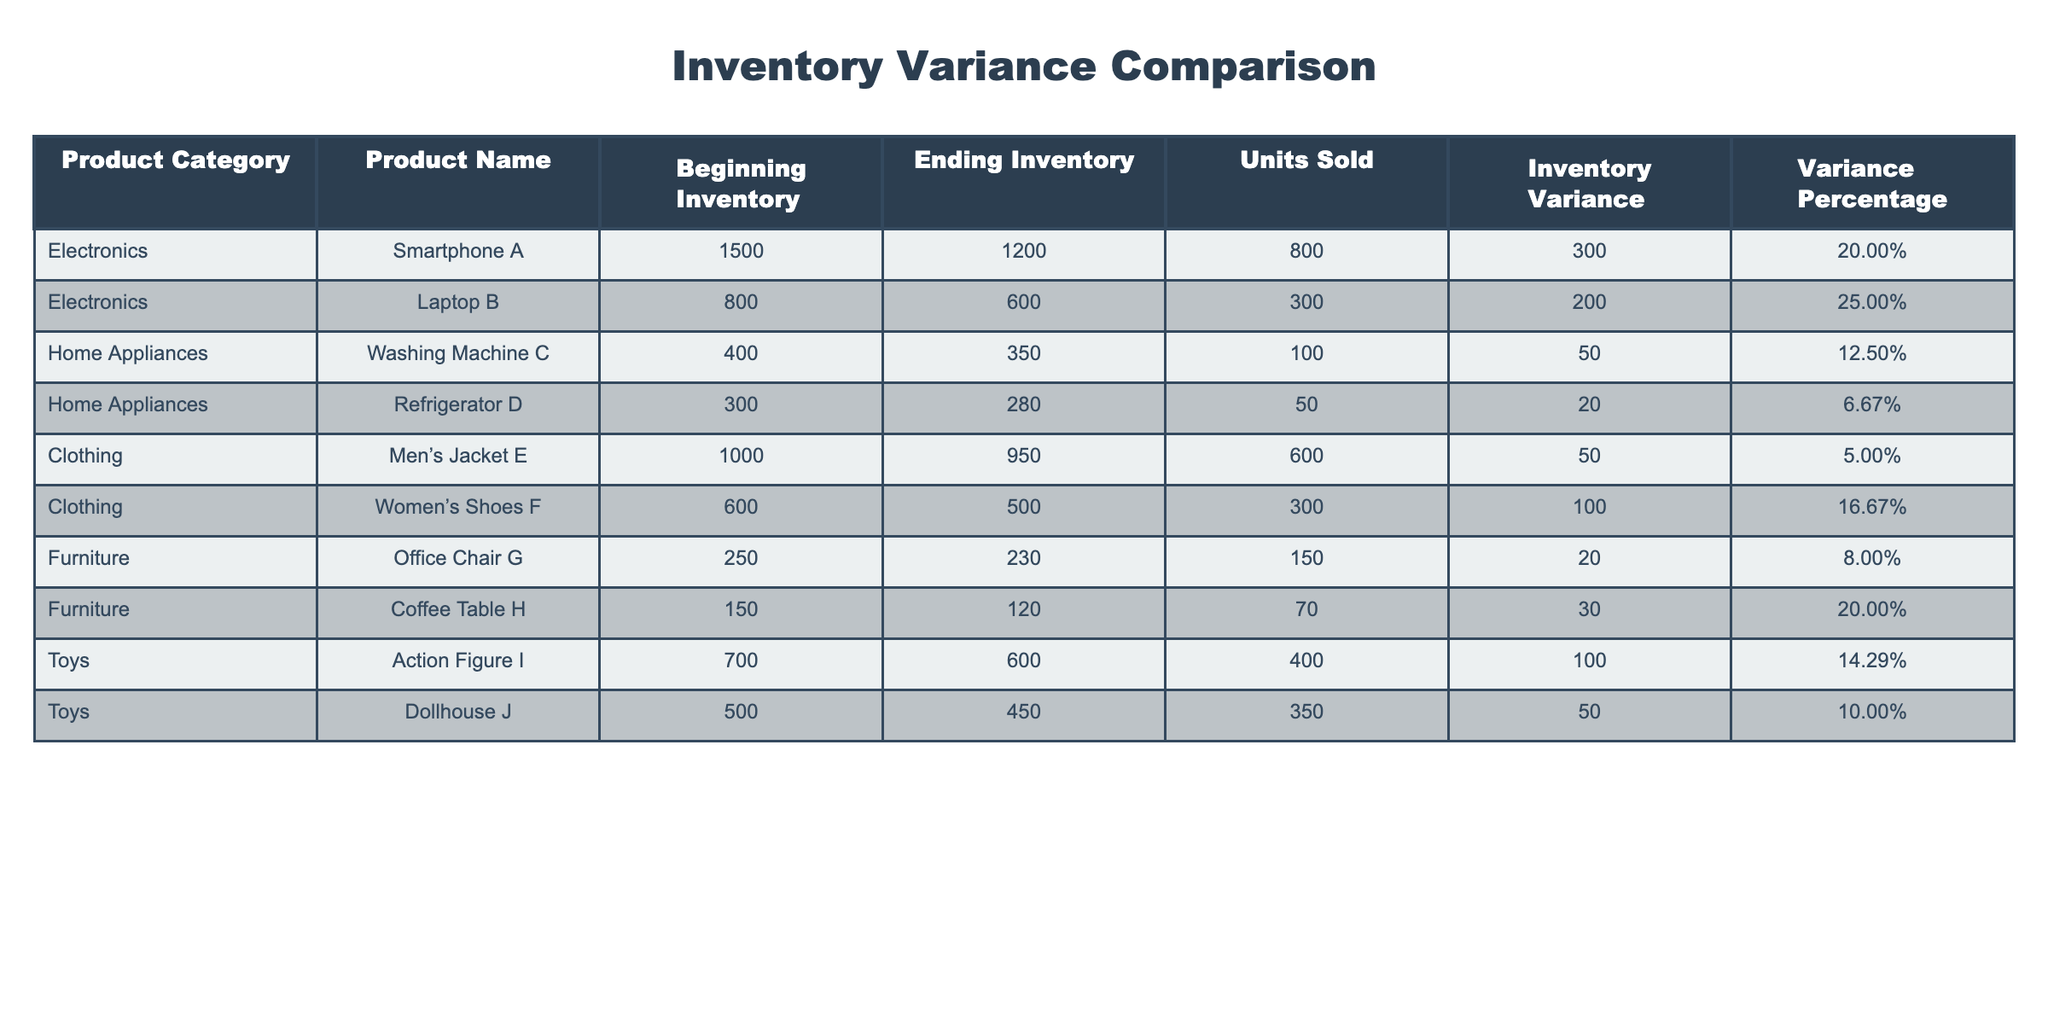What is the inventory variance for Smartphone A? The table states that the inventory variance for Smartphone A is 300.
Answer: 300 Which product category has the highest ending inventory? The ending inventories are: Electronics 1800, Home Appliances 630, Clothing 1450, Furniture 350, and Toys 1050. Electronics has the highest ending inventory of 1800.
Answer: Electronics What is the average inventory variance percentage across all categories? To find the average, add the variance percentages (20.00% + 25.00% + 12.50% + 6.67% + 5.00% + 16.67% + 8.00% + 20.00% + 14.29% + 10.00% =  100.13%) and divide by 10. The average is 10.01%.
Answer: 10.01% Which product sold the most units? Comparing units sold: Smartphone A 800, Laptop B 300, Washing Machine C 100, Refrigerator D 50, Men’s Jacket E 600, Women’s Shoes F 300, Office Chair G 150, Coffee Table H 70, Action Figure I 400, and Dollhouse J 350. Smartphone A sold the most with 800 units.
Answer: Smartphone A Is the variance percentage for Furniture products generally higher than that of Home Appliances? The variance percentages are: Furniture 8.00% and 20.00%, and Home Appliances 12.50% and 6.67%. The average for Furniture is 14.00%, while for Home Appliances it is 9.58%, indicating that Furniture has a slightly higher average variance percentage.
Answer: Yes What is the difference in inventory variance between the highest and lowest product in the Electronics category? In Electronics, Smartphone A has an inventory variance of 300 and Laptop B has 200. The difference is 300 - 200 = 100.
Answer: 100 How many products have an inventory variance percentage above 15%? The products with variances above 15% are Smartphone A (20.00%), Laptop B (25.00%), Women’s Shoes F (16.67%), and Coffee Table H (20.00%). There are 4 products in total.
Answer: 4 What product category shows the least amount of variance across its products? In Home Appliances, the variances are 50 and 20, giving a total of 70. In comparison, other categories show higher totals. Hence, Home Appliances show the least variance.
Answer: Home Appliances 